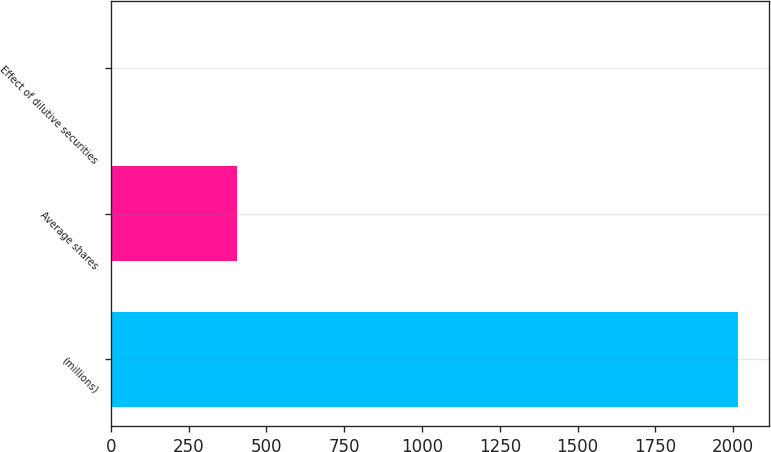Convert chart. <chart><loc_0><loc_0><loc_500><loc_500><bar_chart><fcel>(millions)<fcel>Average shares<fcel>Effect of dilutive securities<nl><fcel>2015<fcel>403.96<fcel>1.2<nl></chart> 